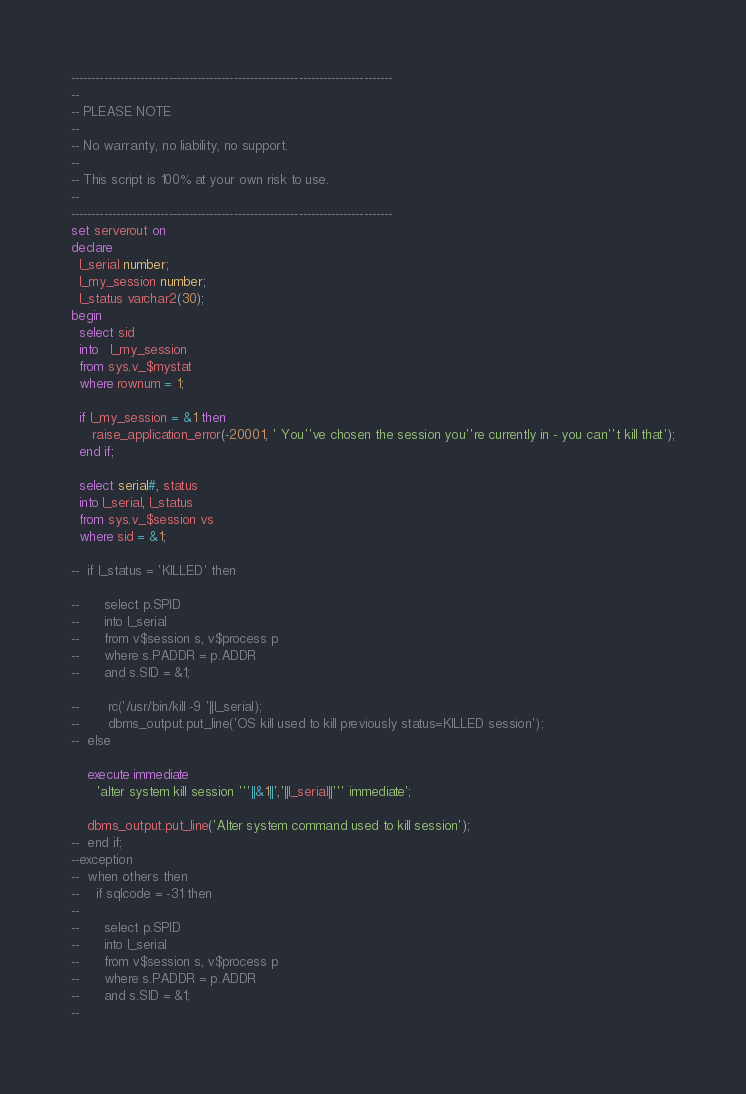<code> <loc_0><loc_0><loc_500><loc_500><_SQL_>-------------------------------------------------------------------------------
--
-- PLEASE NOTE
-- 
-- No warranty, no liability, no support.
--
-- This script is 100% at your own risk to use.
--
-------------------------------------------------------------------------------
set serverout on
declare
  l_serial number;
  l_my_session number;
  l_status varchar2(30);
begin
  select sid 
  into   l_my_session
  from sys.v_$mystat 
  where rownum = 1;

  if l_my_session = &1 then
     raise_application_error(-20001, ' You''ve chosen the session you''re currently in - you can''t kill that');
  end if;

  select serial#, status
  into l_serial, l_status
  from sys.v_$session vs
  where sid = &1;

--  if l_status = 'KILLED' then

--      select p.SPID
--      into l_serial
--      from v$session s, v$process p
--      where s.PADDR = p.ADDR
--      and s.SID = &1;

--       rc('/usr/bin/kill -9 '||l_serial);
--       dbms_output.put_line('OS kill used to kill previously status=KILLED session');
--  else

    execute immediate
      'alter system kill session '''||&1||','||l_serial||''' immediate';

    dbms_output.put_line('Alter system command used to kill session');
--  end if;
--exception
--  when others then
--    if sqlcode = -31 then
--
--      select p.SPID
--      into l_serial
--      from v$session s, v$process p
--      where s.PADDR = p.ADDR
--      and s.SID = &1;
--</code> 